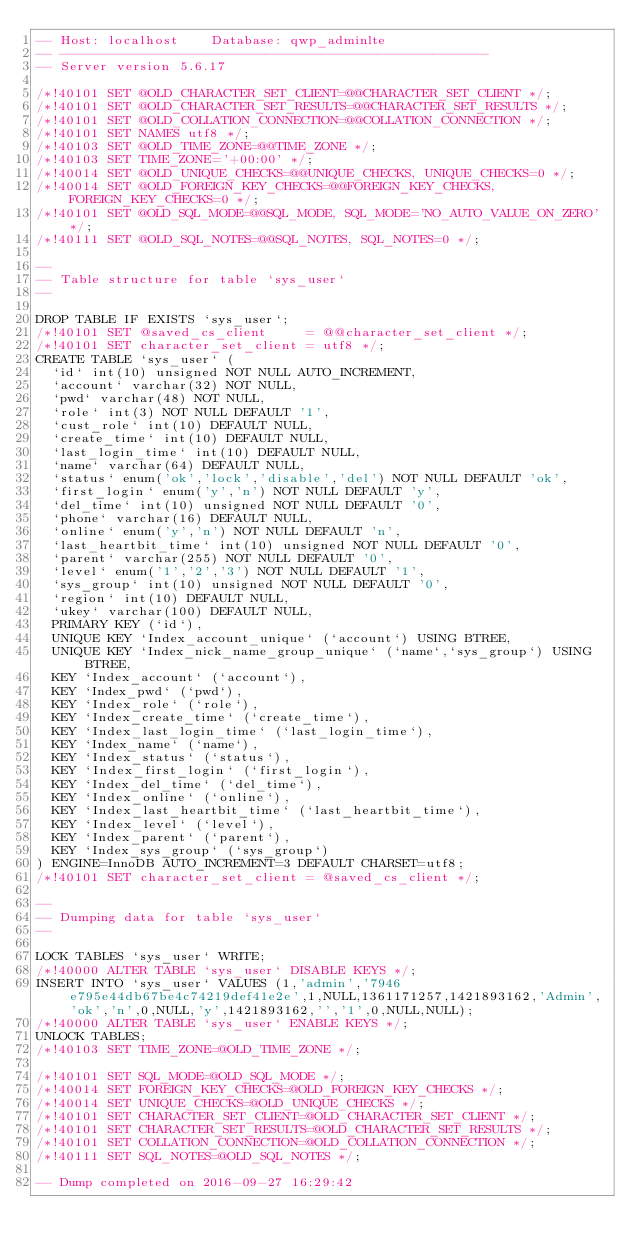<code> <loc_0><loc_0><loc_500><loc_500><_SQL_>-- Host: localhost    Database: qwp_adminlte
-- ------------------------------------------------------
-- Server version	5.6.17

/*!40101 SET @OLD_CHARACTER_SET_CLIENT=@@CHARACTER_SET_CLIENT */;
/*!40101 SET @OLD_CHARACTER_SET_RESULTS=@@CHARACTER_SET_RESULTS */;
/*!40101 SET @OLD_COLLATION_CONNECTION=@@COLLATION_CONNECTION */;
/*!40101 SET NAMES utf8 */;
/*!40103 SET @OLD_TIME_ZONE=@@TIME_ZONE */;
/*!40103 SET TIME_ZONE='+00:00' */;
/*!40014 SET @OLD_UNIQUE_CHECKS=@@UNIQUE_CHECKS, UNIQUE_CHECKS=0 */;
/*!40014 SET @OLD_FOREIGN_KEY_CHECKS=@@FOREIGN_KEY_CHECKS, FOREIGN_KEY_CHECKS=0 */;
/*!40101 SET @OLD_SQL_MODE=@@SQL_MODE, SQL_MODE='NO_AUTO_VALUE_ON_ZERO' */;
/*!40111 SET @OLD_SQL_NOTES=@@SQL_NOTES, SQL_NOTES=0 */;

--
-- Table structure for table `sys_user`
--

DROP TABLE IF EXISTS `sys_user`;
/*!40101 SET @saved_cs_client     = @@character_set_client */;
/*!40101 SET character_set_client = utf8 */;
CREATE TABLE `sys_user` (
  `id` int(10) unsigned NOT NULL AUTO_INCREMENT,
  `account` varchar(32) NOT NULL,
  `pwd` varchar(48) NOT NULL,
  `role` int(3) NOT NULL DEFAULT '1',
  `cust_role` int(10) DEFAULT NULL,
  `create_time` int(10) DEFAULT NULL,
  `last_login_time` int(10) DEFAULT NULL,
  `name` varchar(64) DEFAULT NULL,
  `status` enum('ok','lock','disable','del') NOT NULL DEFAULT 'ok',
  `first_login` enum('y','n') NOT NULL DEFAULT 'y',
  `del_time` int(10) unsigned NOT NULL DEFAULT '0',
  `phone` varchar(16) DEFAULT NULL,
  `online` enum('y','n') NOT NULL DEFAULT 'n',
  `last_heartbit_time` int(10) unsigned NOT NULL DEFAULT '0',
  `parent` varchar(255) NOT NULL DEFAULT '0',
  `level` enum('1','2','3') NOT NULL DEFAULT '1',
  `sys_group` int(10) unsigned NOT NULL DEFAULT '0',
  `region` int(10) DEFAULT NULL,
  `ukey` varchar(100) DEFAULT NULL,
  PRIMARY KEY (`id`),
  UNIQUE KEY `Index_account_unique` (`account`) USING BTREE,
  UNIQUE KEY `Index_nick_name_group_unique` (`name`,`sys_group`) USING BTREE,
  KEY `Index_account` (`account`),
  KEY `Index_pwd` (`pwd`),
  KEY `Index_role` (`role`),
  KEY `Index_create_time` (`create_time`),
  KEY `Index_last_login_time` (`last_login_time`),
  KEY `Index_name` (`name`),
  KEY `Index_status` (`status`),
  KEY `Index_first_login` (`first_login`),
  KEY `Index_del_time` (`del_time`),
  KEY `Index_online` (`online`),
  KEY `Index_last_heartbit_time` (`last_heartbit_time`),
  KEY `Index_level` (`level`),
  KEY `Index_parent` (`parent`),
  KEY `Index_sys_group` (`sys_group`)
) ENGINE=InnoDB AUTO_INCREMENT=3 DEFAULT CHARSET=utf8;
/*!40101 SET character_set_client = @saved_cs_client */;

--
-- Dumping data for table `sys_user`
--

LOCK TABLES `sys_user` WRITE;
/*!40000 ALTER TABLE `sys_user` DISABLE KEYS */;
INSERT INTO `sys_user` VALUES (1,'admin','7946e795e44db67be4c74219def41e2e',1,NULL,1361171257,1421893162,'Admin','ok','n',0,NULL,'y',1421893162,'','1',0,NULL,NULL);
/*!40000 ALTER TABLE `sys_user` ENABLE KEYS */;
UNLOCK TABLES;
/*!40103 SET TIME_ZONE=@OLD_TIME_ZONE */;

/*!40101 SET SQL_MODE=@OLD_SQL_MODE */;
/*!40014 SET FOREIGN_KEY_CHECKS=@OLD_FOREIGN_KEY_CHECKS */;
/*!40014 SET UNIQUE_CHECKS=@OLD_UNIQUE_CHECKS */;
/*!40101 SET CHARACTER_SET_CLIENT=@OLD_CHARACTER_SET_CLIENT */;
/*!40101 SET CHARACTER_SET_RESULTS=@OLD_CHARACTER_SET_RESULTS */;
/*!40101 SET COLLATION_CONNECTION=@OLD_COLLATION_CONNECTION */;
/*!40111 SET SQL_NOTES=@OLD_SQL_NOTES */;

-- Dump completed on 2016-09-27 16:29:42
</code> 